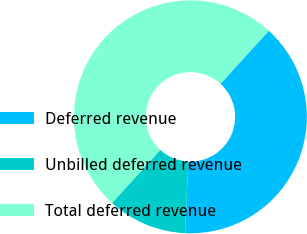Convert chart to OTSL. <chart><loc_0><loc_0><loc_500><loc_500><pie_chart><fcel>Deferred revenue<fcel>Unbilled deferred revenue<fcel>Total deferred revenue<nl><fcel>38.98%<fcel>11.02%<fcel>50.0%<nl></chart> 